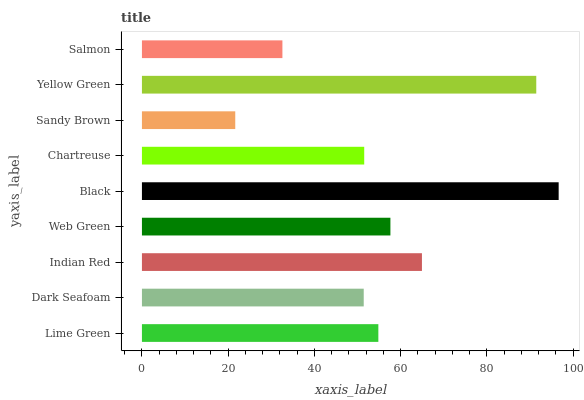Is Sandy Brown the minimum?
Answer yes or no. Yes. Is Black the maximum?
Answer yes or no. Yes. Is Dark Seafoam the minimum?
Answer yes or no. No. Is Dark Seafoam the maximum?
Answer yes or no. No. Is Lime Green greater than Dark Seafoam?
Answer yes or no. Yes. Is Dark Seafoam less than Lime Green?
Answer yes or no. Yes. Is Dark Seafoam greater than Lime Green?
Answer yes or no. No. Is Lime Green less than Dark Seafoam?
Answer yes or no. No. Is Lime Green the high median?
Answer yes or no. Yes. Is Lime Green the low median?
Answer yes or no. Yes. Is Indian Red the high median?
Answer yes or no. No. Is Web Green the low median?
Answer yes or no. No. 